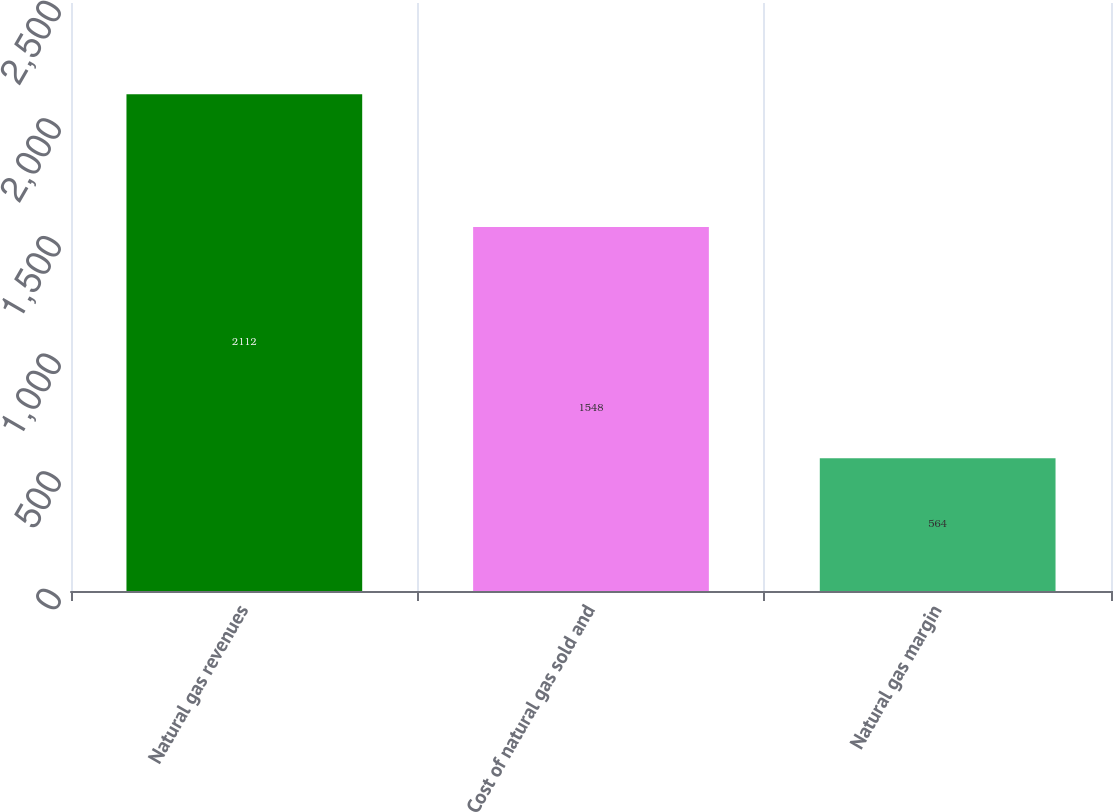<chart> <loc_0><loc_0><loc_500><loc_500><bar_chart><fcel>Natural gas revenues<fcel>Cost of natural gas sold and<fcel>Natural gas margin<nl><fcel>2112<fcel>1548<fcel>564<nl></chart> 